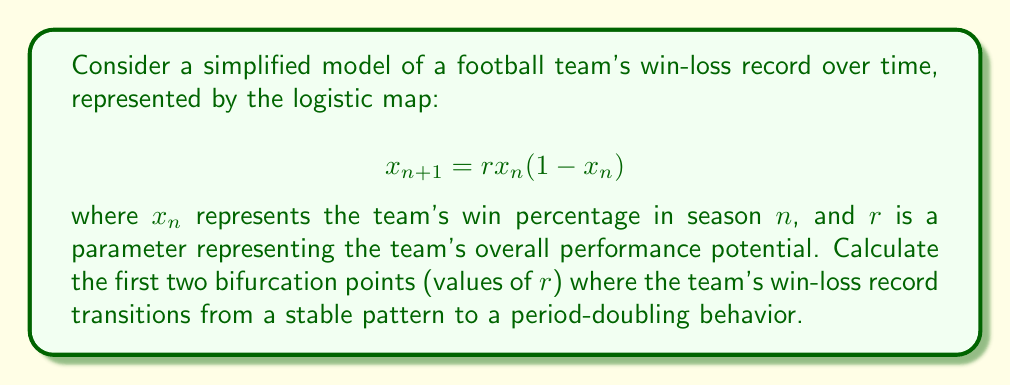Could you help me with this problem? To find the bifurcation points, we need to analyze the stability of the fixed points of the logistic map:

1. Find the fixed points:
   Set $x_{n+1} = x_n = x^*$
   $$x^* = rx^*(1-x^*)$$
   Solving this equation gives two fixed points: $x^*_1 = 0$ and $x^*_2 = 1 - \frac{1}{r}$

2. Analyze stability:
   Calculate the derivative of the map: $f'(x) = r(1-2x)$
   Evaluate at the non-zero fixed point: $f'(x^*_2) = r(1-2(1-\frac{1}{r})) = 2-r$

3. First bifurcation point:
   The first bifurcation occurs when $|f'(x^*_2)| = 1$
   $$|2-r| = 1$$
   Solving this equation: $r_1 = 3$

4. Second bifurcation point:
   After the first bifurcation, the system oscillates between two values. The second bifurcation occurs when this 2-cycle becomes unstable.
   The 2-cycle satisfies: $x_2 = f(f(x_1))$ and $x_1 = f(f(x_2))$
   Stability is lost when $|f'(x_1)f'(x_2)| = 1$
   
   This leads to the equation: $r^2 - 2r - 4 = 0$
   Solving this quadratic equation: $r_2 = 1 + \sqrt{5} \approx 3.236$

Thus, the first two bifurcation points are $r_1 = 3$ and $r_2 = 1 + \sqrt{5}$.
Answer: $r_1 = 3$, $r_2 = 1 + \sqrt{5}$ 